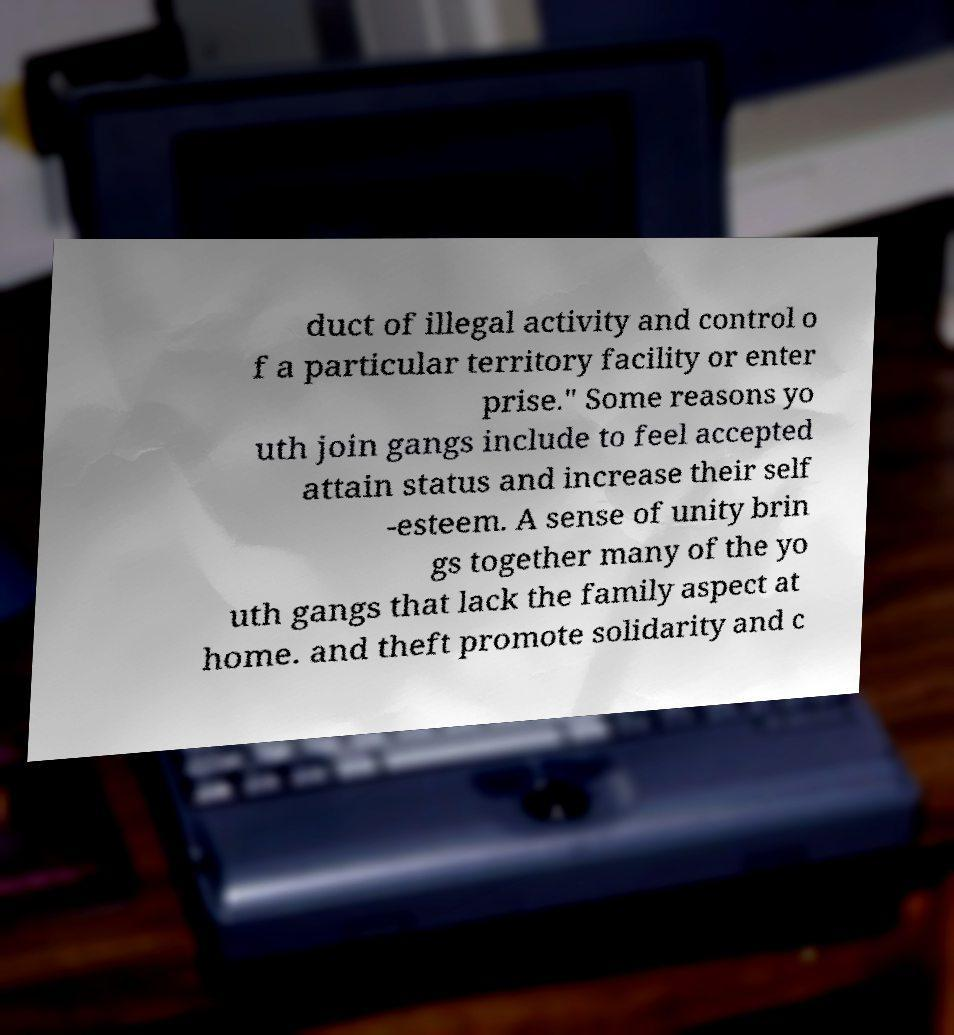Could you extract and type out the text from this image? duct of illegal activity and control o f a particular territory facility or enter prise." Some reasons yo uth join gangs include to feel accepted attain status and increase their self -esteem. A sense of unity brin gs together many of the yo uth gangs that lack the family aspect at home. and theft promote solidarity and c 